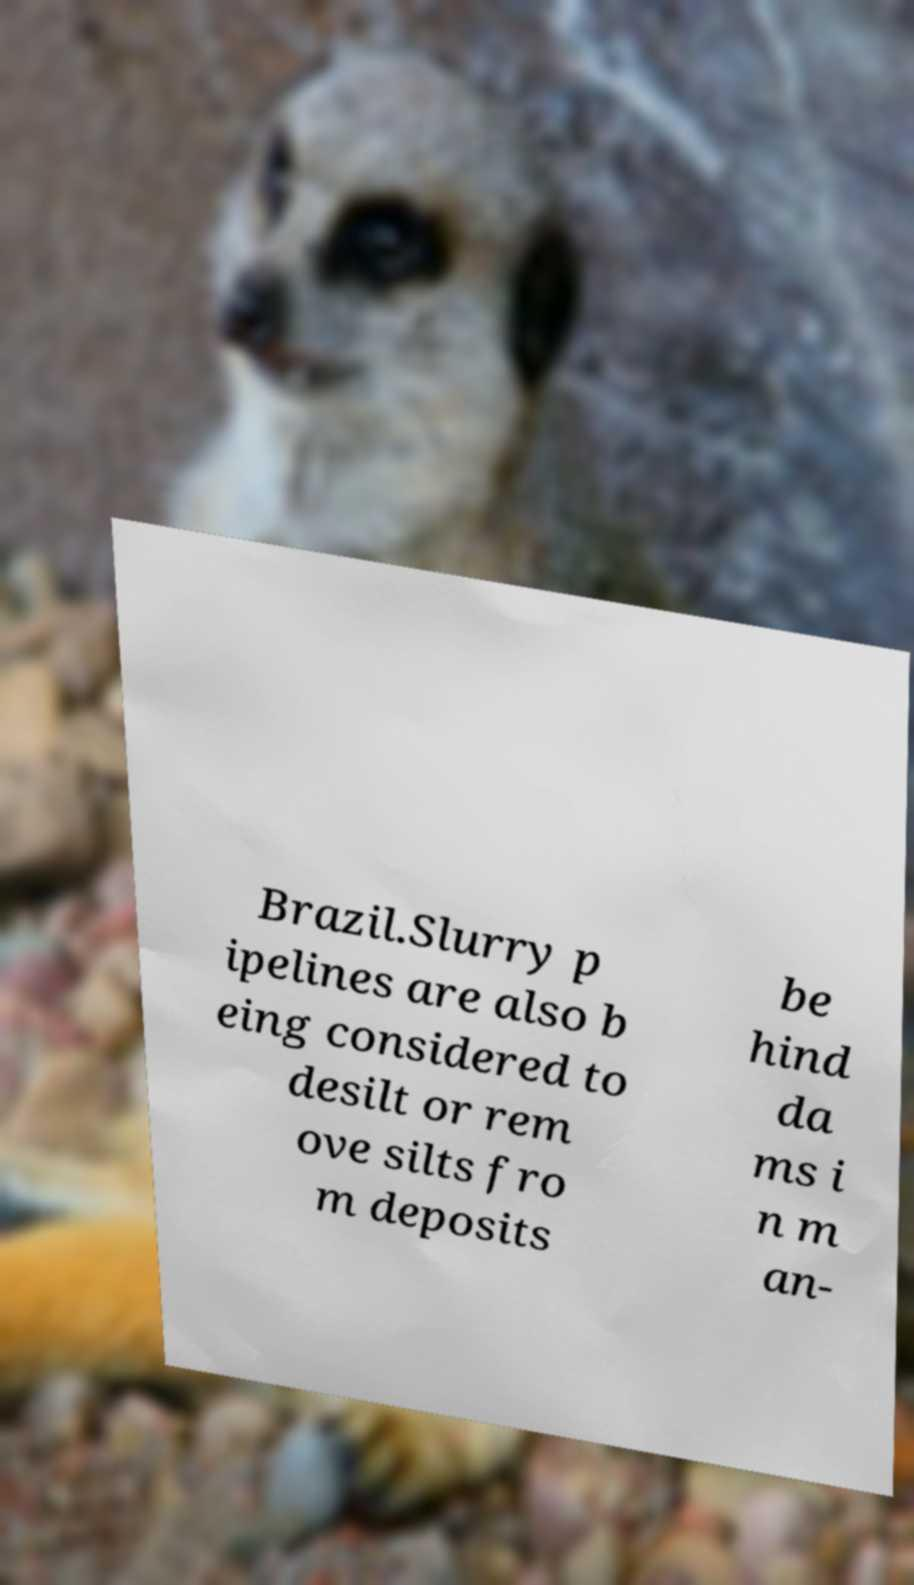Can you read and provide the text displayed in the image?This photo seems to have some interesting text. Can you extract and type it out for me? Brazil.Slurry p ipelines are also b eing considered to desilt or rem ove silts fro m deposits be hind da ms i n m an- 